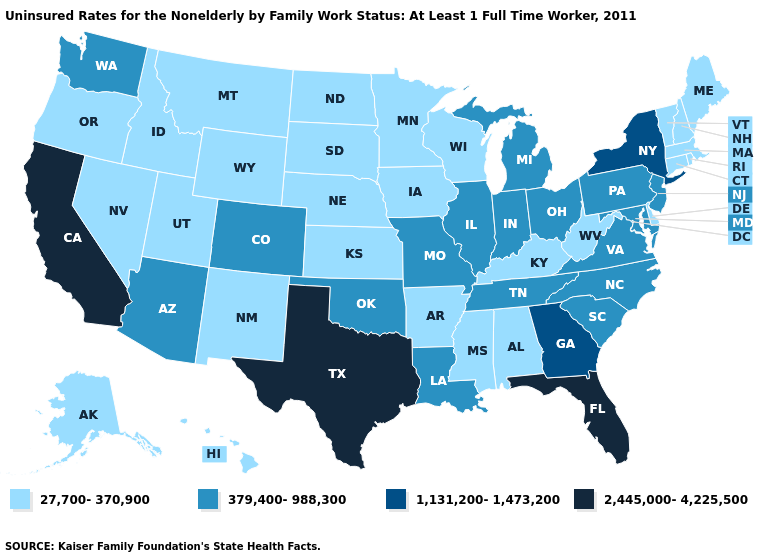Which states have the highest value in the USA?
Answer briefly. California, Florida, Texas. Which states have the highest value in the USA?
Quick response, please. California, Florida, Texas. Which states have the lowest value in the West?
Write a very short answer. Alaska, Hawaii, Idaho, Montana, Nevada, New Mexico, Oregon, Utah, Wyoming. Which states hav the highest value in the West?
Write a very short answer. California. What is the lowest value in states that border South Carolina?
Write a very short answer. 379,400-988,300. Name the states that have a value in the range 2,445,000-4,225,500?
Keep it brief. California, Florida, Texas. Does Mississippi have a lower value than Michigan?
Short answer required. Yes. Does South Carolina have the same value as Alabama?
Give a very brief answer. No. How many symbols are there in the legend?
Quick response, please. 4. Does Florida have a higher value than Connecticut?
Concise answer only. Yes. What is the value of Arkansas?
Be succinct. 27,700-370,900. What is the value of Arkansas?
Quick response, please. 27,700-370,900. What is the value of West Virginia?
Be succinct. 27,700-370,900. What is the value of Rhode Island?
Answer briefly. 27,700-370,900. How many symbols are there in the legend?
Quick response, please. 4. 